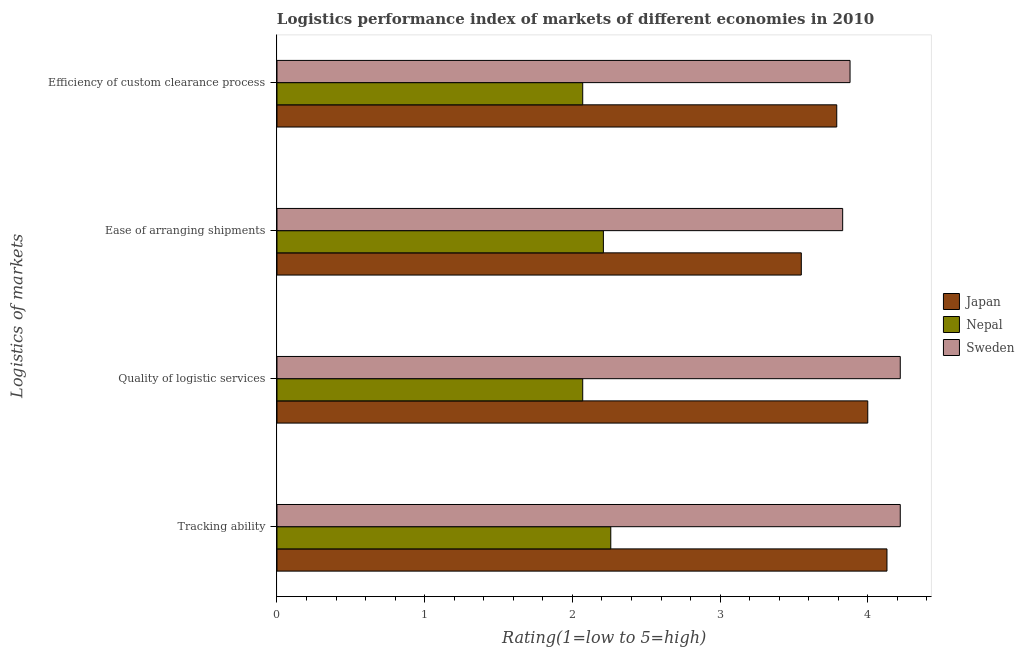How many groups of bars are there?
Offer a very short reply. 4. Are the number of bars on each tick of the Y-axis equal?
Keep it short and to the point. Yes. How many bars are there on the 2nd tick from the top?
Provide a short and direct response. 3. What is the label of the 3rd group of bars from the top?
Your answer should be very brief. Quality of logistic services. What is the lpi rating of quality of logistic services in Sweden?
Your answer should be very brief. 4.22. Across all countries, what is the maximum lpi rating of ease of arranging shipments?
Give a very brief answer. 3.83. Across all countries, what is the minimum lpi rating of quality of logistic services?
Provide a short and direct response. 2.07. In which country was the lpi rating of quality of logistic services maximum?
Your response must be concise. Sweden. In which country was the lpi rating of tracking ability minimum?
Ensure brevity in your answer.  Nepal. What is the total lpi rating of efficiency of custom clearance process in the graph?
Keep it short and to the point. 9.74. What is the difference between the lpi rating of ease of arranging shipments in Sweden and that in Nepal?
Provide a succinct answer. 1.62. What is the difference between the lpi rating of efficiency of custom clearance process in Japan and the lpi rating of ease of arranging shipments in Sweden?
Provide a succinct answer. -0.04. What is the average lpi rating of ease of arranging shipments per country?
Your answer should be very brief. 3.2. What is the difference between the lpi rating of quality of logistic services and lpi rating of tracking ability in Sweden?
Offer a very short reply. 0. What is the ratio of the lpi rating of efficiency of custom clearance process in Japan to that in Sweden?
Provide a succinct answer. 0.98. Is the lpi rating of efficiency of custom clearance process in Japan less than that in Sweden?
Offer a very short reply. Yes. Is the difference between the lpi rating of quality of logistic services in Japan and Sweden greater than the difference between the lpi rating of tracking ability in Japan and Sweden?
Provide a short and direct response. No. What is the difference between the highest and the second highest lpi rating of quality of logistic services?
Give a very brief answer. 0.22. What is the difference between the highest and the lowest lpi rating of efficiency of custom clearance process?
Give a very brief answer. 1.81. Is the sum of the lpi rating of efficiency of custom clearance process in Sweden and Japan greater than the maximum lpi rating of ease of arranging shipments across all countries?
Your answer should be very brief. Yes. Is it the case that in every country, the sum of the lpi rating of ease of arranging shipments and lpi rating of tracking ability is greater than the sum of lpi rating of efficiency of custom clearance process and lpi rating of quality of logistic services?
Give a very brief answer. No. What does the 3rd bar from the bottom in Efficiency of custom clearance process represents?
Offer a terse response. Sweden. How many bars are there?
Your answer should be very brief. 12. How many countries are there in the graph?
Give a very brief answer. 3. What is the difference between two consecutive major ticks on the X-axis?
Your answer should be compact. 1. Does the graph contain grids?
Make the answer very short. No. Where does the legend appear in the graph?
Your answer should be very brief. Center right. How many legend labels are there?
Keep it short and to the point. 3. What is the title of the graph?
Offer a very short reply. Logistics performance index of markets of different economies in 2010. What is the label or title of the X-axis?
Keep it short and to the point. Rating(1=low to 5=high). What is the label or title of the Y-axis?
Your answer should be very brief. Logistics of markets. What is the Rating(1=low to 5=high) of Japan in Tracking ability?
Your response must be concise. 4.13. What is the Rating(1=low to 5=high) of Nepal in Tracking ability?
Ensure brevity in your answer.  2.26. What is the Rating(1=low to 5=high) in Sweden in Tracking ability?
Provide a succinct answer. 4.22. What is the Rating(1=low to 5=high) in Japan in Quality of logistic services?
Ensure brevity in your answer.  4. What is the Rating(1=low to 5=high) in Nepal in Quality of logistic services?
Make the answer very short. 2.07. What is the Rating(1=low to 5=high) in Sweden in Quality of logistic services?
Your answer should be compact. 4.22. What is the Rating(1=low to 5=high) of Japan in Ease of arranging shipments?
Give a very brief answer. 3.55. What is the Rating(1=low to 5=high) in Nepal in Ease of arranging shipments?
Offer a terse response. 2.21. What is the Rating(1=low to 5=high) of Sweden in Ease of arranging shipments?
Your answer should be very brief. 3.83. What is the Rating(1=low to 5=high) of Japan in Efficiency of custom clearance process?
Offer a terse response. 3.79. What is the Rating(1=low to 5=high) of Nepal in Efficiency of custom clearance process?
Keep it short and to the point. 2.07. What is the Rating(1=low to 5=high) of Sweden in Efficiency of custom clearance process?
Make the answer very short. 3.88. Across all Logistics of markets, what is the maximum Rating(1=low to 5=high) in Japan?
Your response must be concise. 4.13. Across all Logistics of markets, what is the maximum Rating(1=low to 5=high) in Nepal?
Ensure brevity in your answer.  2.26. Across all Logistics of markets, what is the maximum Rating(1=low to 5=high) in Sweden?
Ensure brevity in your answer.  4.22. Across all Logistics of markets, what is the minimum Rating(1=low to 5=high) in Japan?
Your response must be concise. 3.55. Across all Logistics of markets, what is the minimum Rating(1=low to 5=high) of Nepal?
Your answer should be very brief. 2.07. Across all Logistics of markets, what is the minimum Rating(1=low to 5=high) in Sweden?
Your answer should be very brief. 3.83. What is the total Rating(1=low to 5=high) of Japan in the graph?
Make the answer very short. 15.47. What is the total Rating(1=low to 5=high) of Nepal in the graph?
Ensure brevity in your answer.  8.61. What is the total Rating(1=low to 5=high) of Sweden in the graph?
Ensure brevity in your answer.  16.15. What is the difference between the Rating(1=low to 5=high) in Japan in Tracking ability and that in Quality of logistic services?
Your response must be concise. 0.13. What is the difference between the Rating(1=low to 5=high) in Nepal in Tracking ability and that in Quality of logistic services?
Offer a very short reply. 0.19. What is the difference between the Rating(1=low to 5=high) of Japan in Tracking ability and that in Ease of arranging shipments?
Ensure brevity in your answer.  0.58. What is the difference between the Rating(1=low to 5=high) of Nepal in Tracking ability and that in Ease of arranging shipments?
Ensure brevity in your answer.  0.05. What is the difference between the Rating(1=low to 5=high) of Sweden in Tracking ability and that in Ease of arranging shipments?
Ensure brevity in your answer.  0.39. What is the difference between the Rating(1=low to 5=high) in Japan in Tracking ability and that in Efficiency of custom clearance process?
Make the answer very short. 0.34. What is the difference between the Rating(1=low to 5=high) in Nepal in Tracking ability and that in Efficiency of custom clearance process?
Provide a short and direct response. 0.19. What is the difference between the Rating(1=low to 5=high) of Sweden in Tracking ability and that in Efficiency of custom clearance process?
Provide a short and direct response. 0.34. What is the difference between the Rating(1=low to 5=high) of Japan in Quality of logistic services and that in Ease of arranging shipments?
Your response must be concise. 0.45. What is the difference between the Rating(1=low to 5=high) of Nepal in Quality of logistic services and that in Ease of arranging shipments?
Your response must be concise. -0.14. What is the difference between the Rating(1=low to 5=high) of Sweden in Quality of logistic services and that in Ease of arranging shipments?
Provide a short and direct response. 0.39. What is the difference between the Rating(1=low to 5=high) in Japan in Quality of logistic services and that in Efficiency of custom clearance process?
Offer a terse response. 0.21. What is the difference between the Rating(1=low to 5=high) of Nepal in Quality of logistic services and that in Efficiency of custom clearance process?
Provide a short and direct response. 0. What is the difference between the Rating(1=low to 5=high) in Sweden in Quality of logistic services and that in Efficiency of custom clearance process?
Your answer should be compact. 0.34. What is the difference between the Rating(1=low to 5=high) of Japan in Ease of arranging shipments and that in Efficiency of custom clearance process?
Your response must be concise. -0.24. What is the difference between the Rating(1=low to 5=high) in Nepal in Ease of arranging shipments and that in Efficiency of custom clearance process?
Ensure brevity in your answer.  0.14. What is the difference between the Rating(1=low to 5=high) in Sweden in Ease of arranging shipments and that in Efficiency of custom clearance process?
Keep it short and to the point. -0.05. What is the difference between the Rating(1=low to 5=high) in Japan in Tracking ability and the Rating(1=low to 5=high) in Nepal in Quality of logistic services?
Offer a terse response. 2.06. What is the difference between the Rating(1=low to 5=high) in Japan in Tracking ability and the Rating(1=low to 5=high) in Sweden in Quality of logistic services?
Your answer should be compact. -0.09. What is the difference between the Rating(1=low to 5=high) in Nepal in Tracking ability and the Rating(1=low to 5=high) in Sweden in Quality of logistic services?
Offer a terse response. -1.96. What is the difference between the Rating(1=low to 5=high) in Japan in Tracking ability and the Rating(1=low to 5=high) in Nepal in Ease of arranging shipments?
Make the answer very short. 1.92. What is the difference between the Rating(1=low to 5=high) of Nepal in Tracking ability and the Rating(1=low to 5=high) of Sweden in Ease of arranging shipments?
Offer a very short reply. -1.57. What is the difference between the Rating(1=low to 5=high) of Japan in Tracking ability and the Rating(1=low to 5=high) of Nepal in Efficiency of custom clearance process?
Your answer should be compact. 2.06. What is the difference between the Rating(1=low to 5=high) of Japan in Tracking ability and the Rating(1=low to 5=high) of Sweden in Efficiency of custom clearance process?
Give a very brief answer. 0.25. What is the difference between the Rating(1=low to 5=high) in Nepal in Tracking ability and the Rating(1=low to 5=high) in Sweden in Efficiency of custom clearance process?
Provide a short and direct response. -1.62. What is the difference between the Rating(1=low to 5=high) of Japan in Quality of logistic services and the Rating(1=low to 5=high) of Nepal in Ease of arranging shipments?
Offer a very short reply. 1.79. What is the difference between the Rating(1=low to 5=high) of Japan in Quality of logistic services and the Rating(1=low to 5=high) of Sweden in Ease of arranging shipments?
Offer a very short reply. 0.17. What is the difference between the Rating(1=low to 5=high) of Nepal in Quality of logistic services and the Rating(1=low to 5=high) of Sweden in Ease of arranging shipments?
Keep it short and to the point. -1.76. What is the difference between the Rating(1=low to 5=high) in Japan in Quality of logistic services and the Rating(1=low to 5=high) in Nepal in Efficiency of custom clearance process?
Give a very brief answer. 1.93. What is the difference between the Rating(1=low to 5=high) of Japan in Quality of logistic services and the Rating(1=low to 5=high) of Sweden in Efficiency of custom clearance process?
Keep it short and to the point. 0.12. What is the difference between the Rating(1=low to 5=high) of Nepal in Quality of logistic services and the Rating(1=low to 5=high) of Sweden in Efficiency of custom clearance process?
Your answer should be compact. -1.81. What is the difference between the Rating(1=low to 5=high) of Japan in Ease of arranging shipments and the Rating(1=low to 5=high) of Nepal in Efficiency of custom clearance process?
Make the answer very short. 1.48. What is the difference between the Rating(1=low to 5=high) of Japan in Ease of arranging shipments and the Rating(1=low to 5=high) of Sweden in Efficiency of custom clearance process?
Your answer should be compact. -0.33. What is the difference between the Rating(1=low to 5=high) of Nepal in Ease of arranging shipments and the Rating(1=low to 5=high) of Sweden in Efficiency of custom clearance process?
Offer a terse response. -1.67. What is the average Rating(1=low to 5=high) in Japan per Logistics of markets?
Give a very brief answer. 3.87. What is the average Rating(1=low to 5=high) of Nepal per Logistics of markets?
Your response must be concise. 2.15. What is the average Rating(1=low to 5=high) in Sweden per Logistics of markets?
Keep it short and to the point. 4.04. What is the difference between the Rating(1=low to 5=high) in Japan and Rating(1=low to 5=high) in Nepal in Tracking ability?
Offer a terse response. 1.87. What is the difference between the Rating(1=low to 5=high) of Japan and Rating(1=low to 5=high) of Sweden in Tracking ability?
Your answer should be very brief. -0.09. What is the difference between the Rating(1=low to 5=high) in Nepal and Rating(1=low to 5=high) in Sweden in Tracking ability?
Offer a very short reply. -1.96. What is the difference between the Rating(1=low to 5=high) in Japan and Rating(1=low to 5=high) in Nepal in Quality of logistic services?
Keep it short and to the point. 1.93. What is the difference between the Rating(1=low to 5=high) in Japan and Rating(1=low to 5=high) in Sweden in Quality of logistic services?
Make the answer very short. -0.22. What is the difference between the Rating(1=low to 5=high) of Nepal and Rating(1=low to 5=high) of Sweden in Quality of logistic services?
Make the answer very short. -2.15. What is the difference between the Rating(1=low to 5=high) in Japan and Rating(1=low to 5=high) in Nepal in Ease of arranging shipments?
Provide a short and direct response. 1.34. What is the difference between the Rating(1=low to 5=high) of Japan and Rating(1=low to 5=high) of Sweden in Ease of arranging shipments?
Provide a succinct answer. -0.28. What is the difference between the Rating(1=low to 5=high) in Nepal and Rating(1=low to 5=high) in Sweden in Ease of arranging shipments?
Provide a short and direct response. -1.62. What is the difference between the Rating(1=low to 5=high) of Japan and Rating(1=low to 5=high) of Nepal in Efficiency of custom clearance process?
Make the answer very short. 1.72. What is the difference between the Rating(1=low to 5=high) in Japan and Rating(1=low to 5=high) in Sweden in Efficiency of custom clearance process?
Ensure brevity in your answer.  -0.09. What is the difference between the Rating(1=low to 5=high) of Nepal and Rating(1=low to 5=high) of Sweden in Efficiency of custom clearance process?
Provide a succinct answer. -1.81. What is the ratio of the Rating(1=low to 5=high) of Japan in Tracking ability to that in Quality of logistic services?
Make the answer very short. 1.03. What is the ratio of the Rating(1=low to 5=high) of Nepal in Tracking ability to that in Quality of logistic services?
Keep it short and to the point. 1.09. What is the ratio of the Rating(1=low to 5=high) in Sweden in Tracking ability to that in Quality of logistic services?
Your response must be concise. 1. What is the ratio of the Rating(1=low to 5=high) in Japan in Tracking ability to that in Ease of arranging shipments?
Offer a very short reply. 1.16. What is the ratio of the Rating(1=low to 5=high) in Nepal in Tracking ability to that in Ease of arranging shipments?
Ensure brevity in your answer.  1.02. What is the ratio of the Rating(1=low to 5=high) of Sweden in Tracking ability to that in Ease of arranging shipments?
Ensure brevity in your answer.  1.1. What is the ratio of the Rating(1=low to 5=high) of Japan in Tracking ability to that in Efficiency of custom clearance process?
Provide a succinct answer. 1.09. What is the ratio of the Rating(1=low to 5=high) of Nepal in Tracking ability to that in Efficiency of custom clearance process?
Offer a very short reply. 1.09. What is the ratio of the Rating(1=low to 5=high) in Sweden in Tracking ability to that in Efficiency of custom clearance process?
Offer a very short reply. 1.09. What is the ratio of the Rating(1=low to 5=high) in Japan in Quality of logistic services to that in Ease of arranging shipments?
Offer a very short reply. 1.13. What is the ratio of the Rating(1=low to 5=high) in Nepal in Quality of logistic services to that in Ease of arranging shipments?
Your response must be concise. 0.94. What is the ratio of the Rating(1=low to 5=high) of Sweden in Quality of logistic services to that in Ease of arranging shipments?
Your answer should be very brief. 1.1. What is the ratio of the Rating(1=low to 5=high) in Japan in Quality of logistic services to that in Efficiency of custom clearance process?
Ensure brevity in your answer.  1.06. What is the ratio of the Rating(1=low to 5=high) of Nepal in Quality of logistic services to that in Efficiency of custom clearance process?
Your answer should be very brief. 1. What is the ratio of the Rating(1=low to 5=high) in Sweden in Quality of logistic services to that in Efficiency of custom clearance process?
Your answer should be very brief. 1.09. What is the ratio of the Rating(1=low to 5=high) in Japan in Ease of arranging shipments to that in Efficiency of custom clearance process?
Your answer should be compact. 0.94. What is the ratio of the Rating(1=low to 5=high) in Nepal in Ease of arranging shipments to that in Efficiency of custom clearance process?
Give a very brief answer. 1.07. What is the ratio of the Rating(1=low to 5=high) of Sweden in Ease of arranging shipments to that in Efficiency of custom clearance process?
Make the answer very short. 0.99. What is the difference between the highest and the second highest Rating(1=low to 5=high) of Japan?
Give a very brief answer. 0.13. What is the difference between the highest and the second highest Rating(1=low to 5=high) in Sweden?
Your answer should be very brief. 0. What is the difference between the highest and the lowest Rating(1=low to 5=high) in Japan?
Offer a very short reply. 0.58. What is the difference between the highest and the lowest Rating(1=low to 5=high) in Nepal?
Your answer should be very brief. 0.19. What is the difference between the highest and the lowest Rating(1=low to 5=high) of Sweden?
Keep it short and to the point. 0.39. 